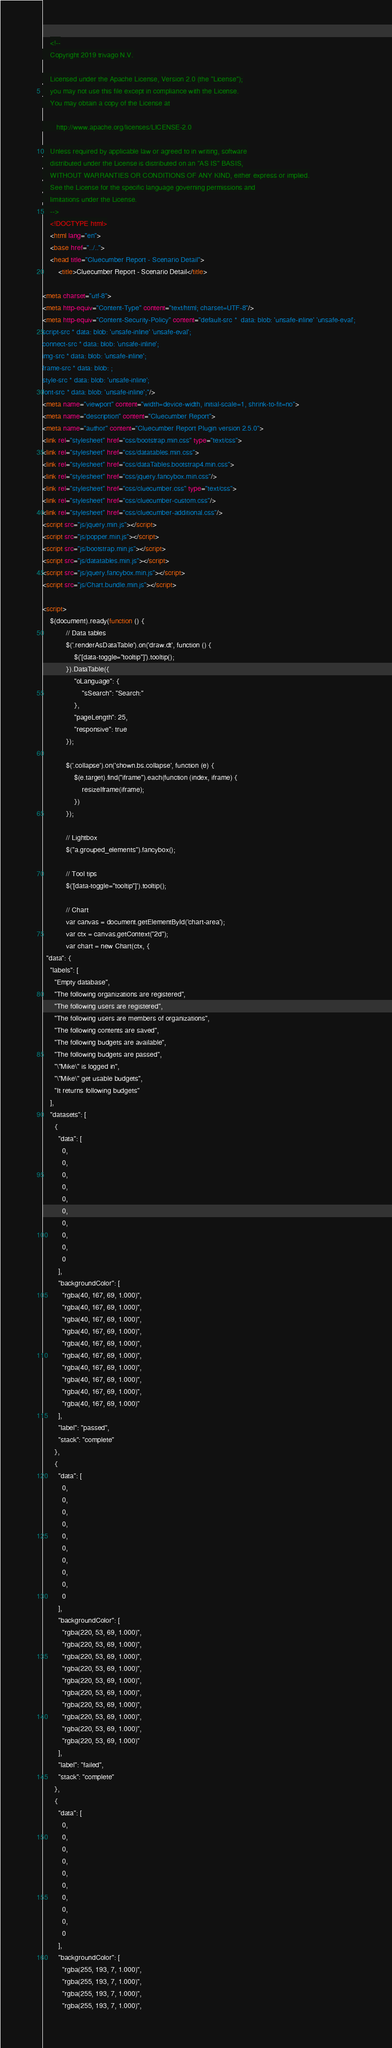<code> <loc_0><loc_0><loc_500><loc_500><_HTML_>
    <!--
    Copyright 2019 trivago N.V.

    Licensed under the Apache License, Version 2.0 (the "License");
    you may not use this file except in compliance with the License.
    You may obtain a copy of the License at

       http://www.apache.org/licenses/LICENSE-2.0

    Unless required by applicable law or agreed to in writing, software
    distributed under the License is distributed on an "AS IS" BASIS,
    WITHOUT WARRANTIES OR CONDITIONS OF ANY KIND, either express or implied.
    See the License for the specific language governing permissions and
    limitations under the License.
    -->
    <!DOCTYPE html>
    <html lang="en">
    <base href="../..">
    <head title="Cluecumber Report - Scenario Detail">
        <title>Cluecumber Report - Scenario Detail</title>

<meta charset="utf-8">
<meta http-equiv="Content-Type" content="text/html; charset=UTF-8"/>
<meta http-equiv="Content-Security-Policy" content="default-src *  data: blob: 'unsafe-inline' 'unsafe-eval';
script-src * data: blob: 'unsafe-inline' 'unsafe-eval';
connect-src * data: blob: 'unsafe-inline';
img-src * data: blob: 'unsafe-inline';
frame-src * data: blob: ;
style-src * data: blob: 'unsafe-inline';
font-src * data: blob: 'unsafe-inline';"/>
<meta name="viewport" content="width=device-width, initial-scale=1, shrink-to-fit=no">
<meta name="description" content="Cluecumber Report">
<meta name="author" content="Cluecumber Report Plugin version 2.5.0">
<link rel="stylesheet" href="css/bootstrap.min.css" type="text/css">
<link rel="stylesheet" href="css/datatables.min.css">
<link rel="stylesheet" href="css/dataTables.bootstrap4.min.css">
<link rel="stylesheet" href="css/jquery.fancybox.min.css"/>
<link rel="stylesheet" href="css/cluecumber.css" type="text/css">
<link rel="stylesheet" href="css/cluecumber-custom.css"/>
<link rel="stylesheet" href="css/cluecumber-additional.css"/>
<script src="js/jquery.min.js"></script>
<script src="js/popper.min.js"></script>
<script src="js/bootstrap.min.js"></script>
<script src="js/datatables.min.js"></script>
<script src="js/jquery.fancybox.min.js"></script>
<script src="js/Chart.bundle.min.js"></script>

<script>
    $(document).ready(function () {
            // Data tables
            $('.renderAsDataTable').on('draw.dt', function () {
                $('[data-toggle="tooltip"]').tooltip();
            }).DataTable({
                "oLanguage": {
                    "sSearch": "Search:"
                },
                "pageLength": 25,
                "responsive": true
            });

            $('.collapse').on('shown.bs.collapse', function (e) {
                $(e.target).find("iframe").each(function (index, iframe) {
                    resizeIframe(iframe);
                })
            });

            // Lightbox
            $("a.grouped_elements").fancybox();

            // Tool tips
            $('[data-toggle="tooltip"]').tooltip();

            // Chart
            var canvas = document.getElementById('chart-area');
            var ctx = canvas.getContext("2d");
            var chart = new Chart(ctx, {
  "data": {
    "labels": [
      "Empty database",
      "The following organizations are registered",
      "The following users are registered",
      "The following users are members of organizations",
      "The following contents are saved",
      "The following budgets are available",
      "The following budgets are passed",
      "\"Mike\" is logged in",
      "\"Mike\" get usable budgets",
      "It returns following budgets"
    ],
    "datasets": [
      {
        "data": [
          0,
          0,
          0,
          0,
          0,
          0,
          0,
          0,
          0,
          0
        ],
        "backgroundColor": [
          "rgba(40, 167, 69, 1.000)",
          "rgba(40, 167, 69, 1.000)",
          "rgba(40, 167, 69, 1.000)",
          "rgba(40, 167, 69, 1.000)",
          "rgba(40, 167, 69, 1.000)",
          "rgba(40, 167, 69, 1.000)",
          "rgba(40, 167, 69, 1.000)",
          "rgba(40, 167, 69, 1.000)",
          "rgba(40, 167, 69, 1.000)",
          "rgba(40, 167, 69, 1.000)"
        ],
        "label": "passed",
        "stack": "complete"
      },
      {
        "data": [
          0,
          0,
          0,
          0,
          0,
          0,
          0,
          0,
          0,
          0
        ],
        "backgroundColor": [
          "rgba(220, 53, 69, 1.000)",
          "rgba(220, 53, 69, 1.000)",
          "rgba(220, 53, 69, 1.000)",
          "rgba(220, 53, 69, 1.000)",
          "rgba(220, 53, 69, 1.000)",
          "rgba(220, 53, 69, 1.000)",
          "rgba(220, 53, 69, 1.000)",
          "rgba(220, 53, 69, 1.000)",
          "rgba(220, 53, 69, 1.000)",
          "rgba(220, 53, 69, 1.000)"
        ],
        "label": "failed",
        "stack": "complete"
      },
      {
        "data": [
          0,
          0,
          0,
          0,
          0,
          0,
          0,
          0,
          0,
          0
        ],
        "backgroundColor": [
          "rgba(255, 193, 7, 1.000)",
          "rgba(255, 193, 7, 1.000)",
          "rgba(255, 193, 7, 1.000)",
          "rgba(255, 193, 7, 1.000)",</code> 